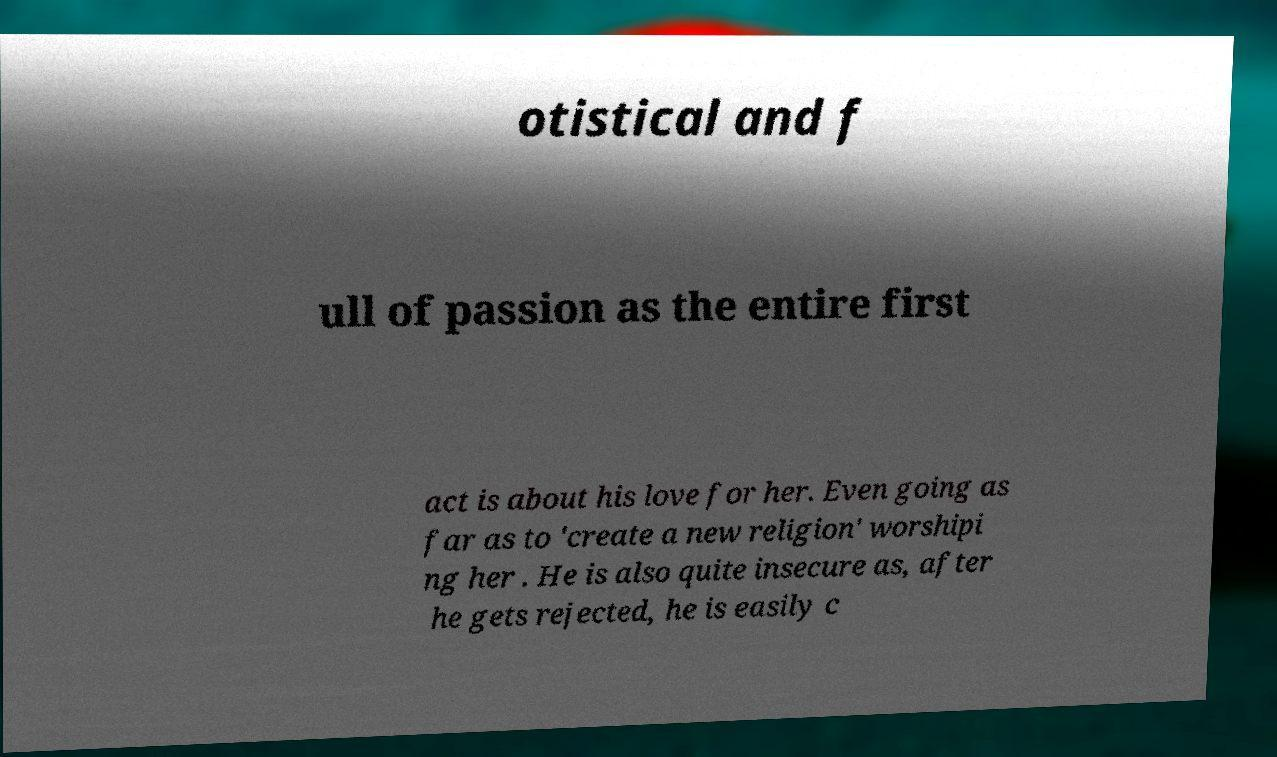For documentation purposes, I need the text within this image transcribed. Could you provide that? otistical and f ull of passion as the entire first act is about his love for her. Even going as far as to 'create a new religion' worshipi ng her . He is also quite insecure as, after he gets rejected, he is easily c 